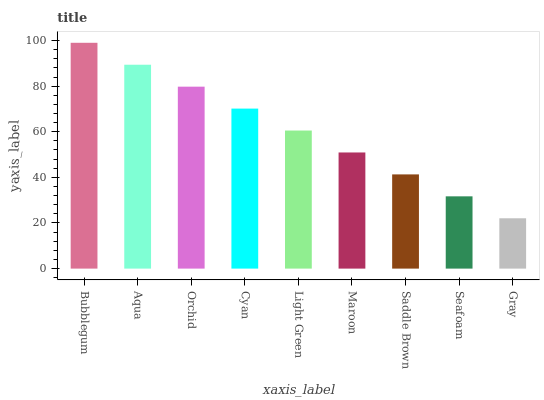Is Gray the minimum?
Answer yes or no. Yes. Is Bubblegum the maximum?
Answer yes or no. Yes. Is Aqua the minimum?
Answer yes or no. No. Is Aqua the maximum?
Answer yes or no. No. Is Bubblegum greater than Aqua?
Answer yes or no. Yes. Is Aqua less than Bubblegum?
Answer yes or no. Yes. Is Aqua greater than Bubblegum?
Answer yes or no. No. Is Bubblegum less than Aqua?
Answer yes or no. No. Is Light Green the high median?
Answer yes or no. Yes. Is Light Green the low median?
Answer yes or no. Yes. Is Aqua the high median?
Answer yes or no. No. Is Maroon the low median?
Answer yes or no. No. 